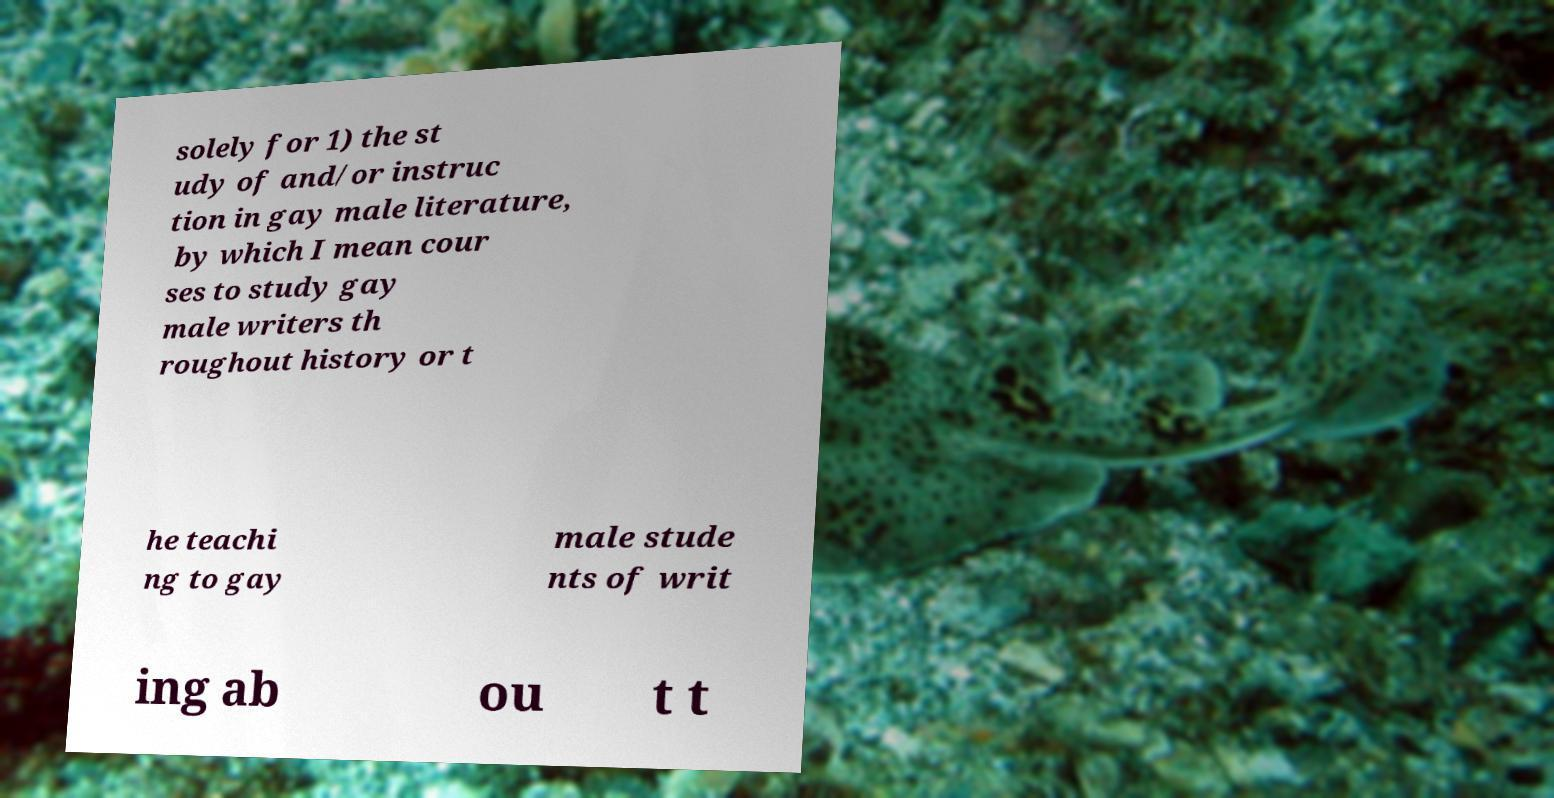There's text embedded in this image that I need extracted. Can you transcribe it verbatim? solely for 1) the st udy of and/or instruc tion in gay male literature, by which I mean cour ses to study gay male writers th roughout history or t he teachi ng to gay male stude nts of writ ing ab ou t t 